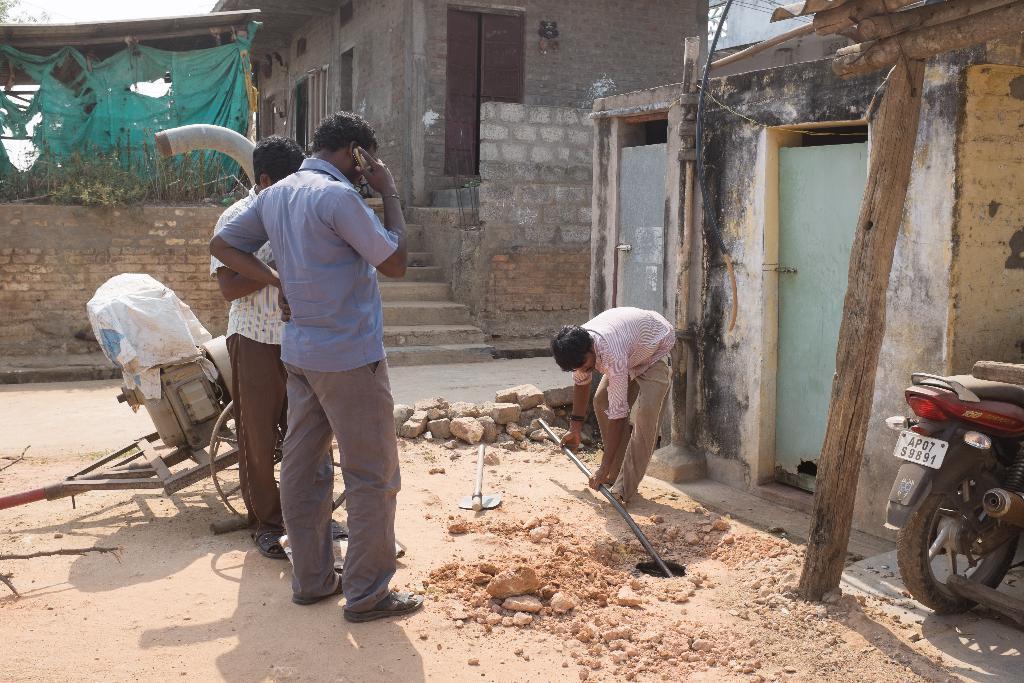In one or two sentences, can you explain what this image depicts? In the image there are two men standing. Behind them there is a motor. In front of them there is a man bending and holding a rod in his hand. In the background there is a building with walls, windows, steps and also there is shed with roof and cloth. On the right corner of the image there is a bike. Beside the bike there is a room with walls, doors pipe. On the ground there are stones and also there is a hole. 